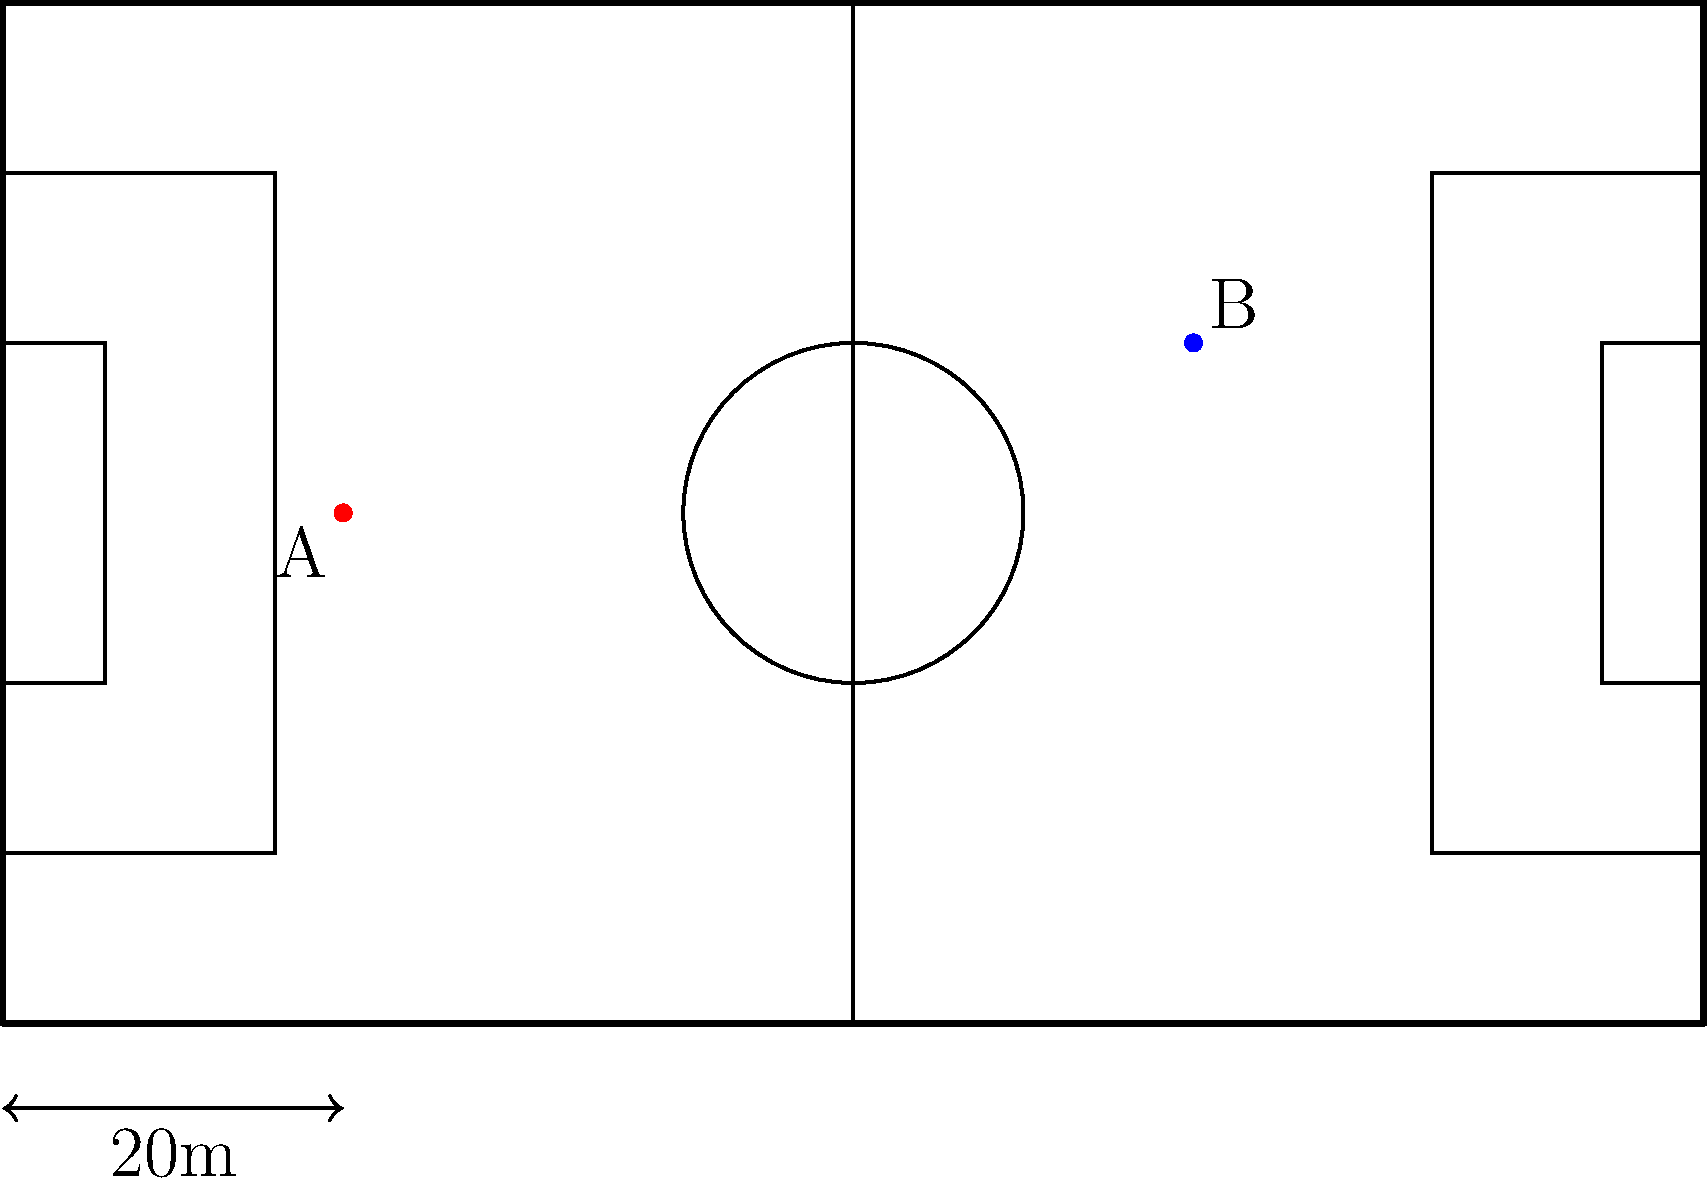In the scaled soccer pitch layout above, players A and B are positioned as shown. The scale indicates that 2 cm on the diagram represents 20 meters on the actual pitch. Estimate the distance between players A and B to the nearest meter. To estimate the distance between players A and B, we'll follow these steps:

1. Measure the distance between A and B on the diagram:
   The diagonal distance is approximately 5.1 cm.

2. Set up a proportion to convert the diagram distance to actual distance:
   $\frac{2 \text{ cm}}{20 \text{ m}} = \frac{5.1 \text{ cm}}{x \text{ m}}$

3. Cross multiply:
   $2x = 20 \cdot 5.1$

4. Solve for x:
   $x = \frac{20 \cdot 5.1}{2} = 51 \text{ m}$

5. Round to the nearest meter:
   51 meters

This estimation method provides a quick way to gauge distances on the pitch, which is crucial for planning team formations and understanding spatial relationships between players.
Answer: 51 meters 